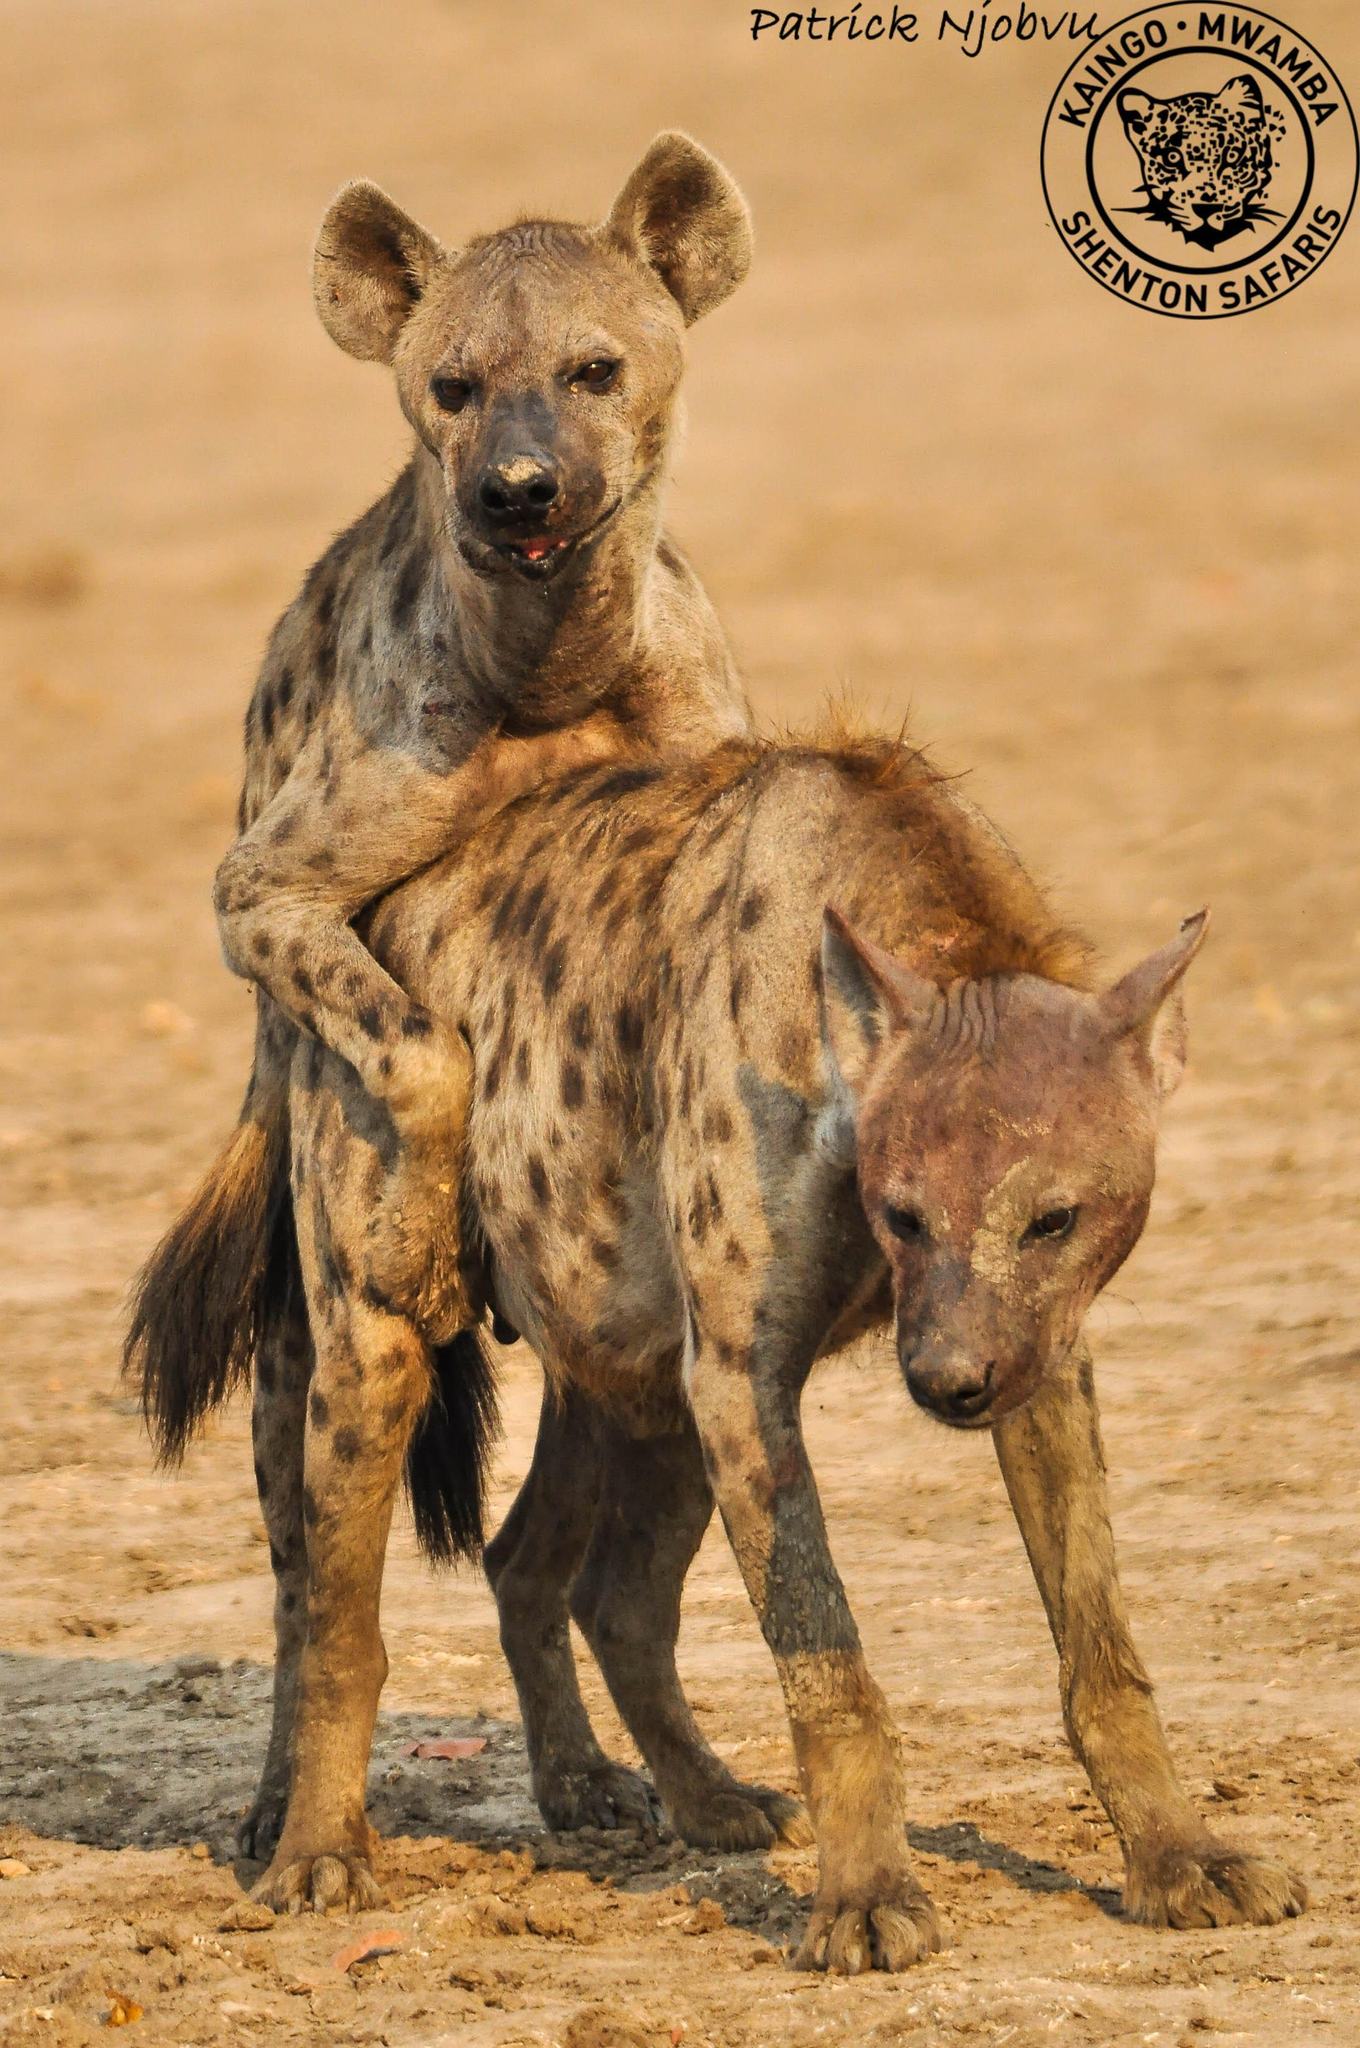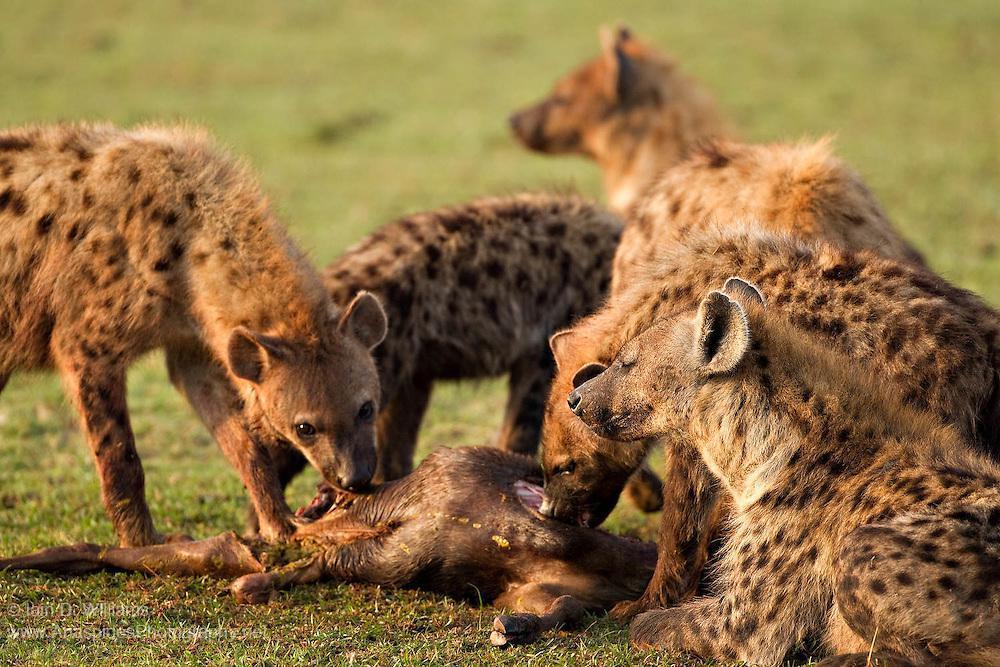The first image is the image on the left, the second image is the image on the right. For the images displayed, is the sentence "A predator and its prey are facing off in the image on the right." factually correct? Answer yes or no. No. The first image is the image on the left, the second image is the image on the right. Assess this claim about the two images: "An image shows a hyena facing a smaller fox-like animal.". Correct or not? Answer yes or no. No. 